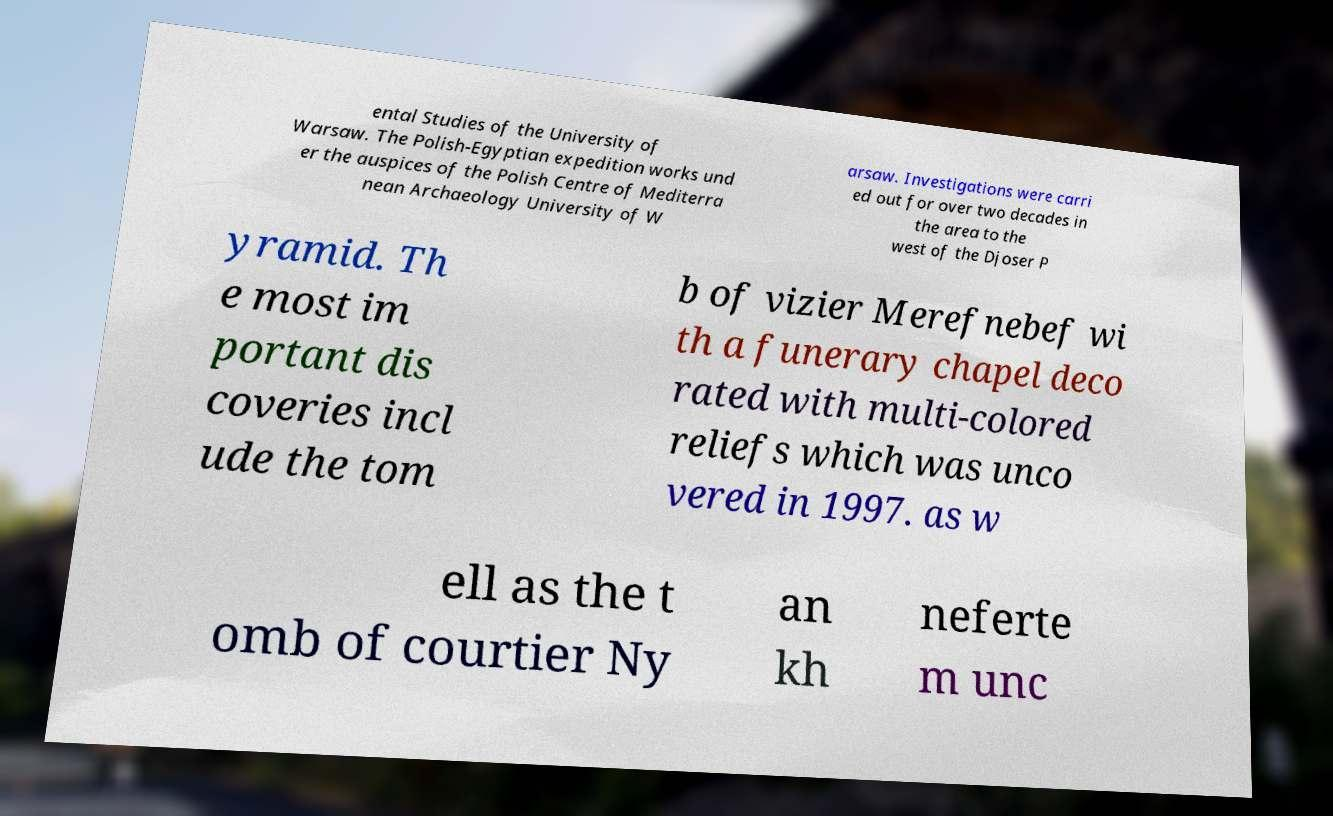Please read and relay the text visible in this image. What does it say? ental Studies of the University of Warsaw. The Polish-Egyptian expedition works und er the auspices of the Polish Centre of Mediterra nean Archaeology University of W arsaw. Investigations were carri ed out for over two decades in the area to the west of the Djoser P yramid. Th e most im portant dis coveries incl ude the tom b of vizier Merefnebef wi th a funerary chapel deco rated with multi-colored reliefs which was unco vered in 1997. as w ell as the t omb of courtier Ny an kh neferte m unc 